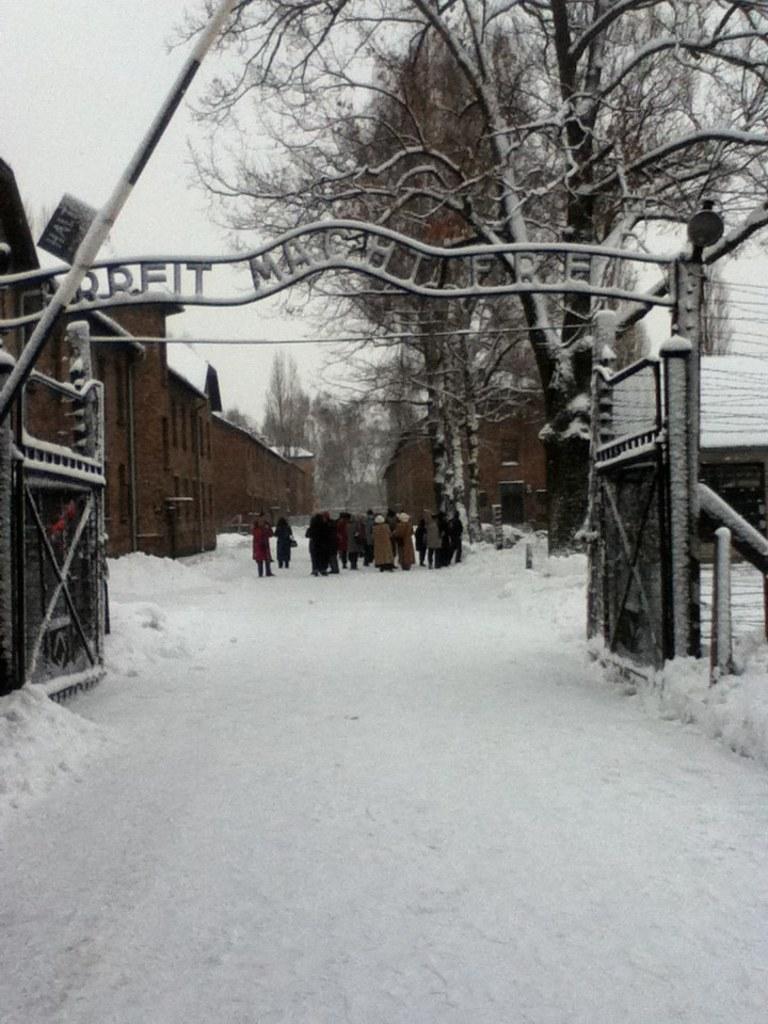Can you describe this image briefly? There are group of people standing. These are the iron gates and a name board. This is the snow. These are the buildings. These are the trees, which are partially covered with the snow. 